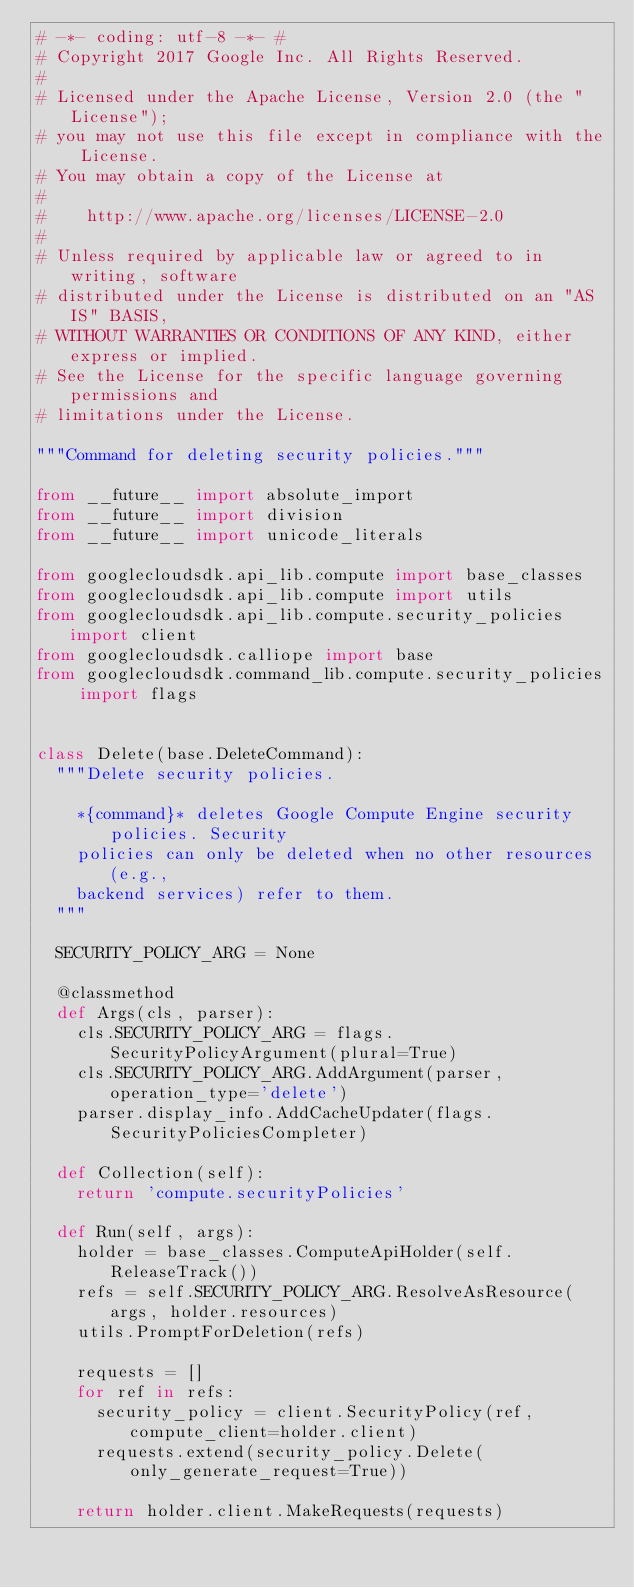Convert code to text. <code><loc_0><loc_0><loc_500><loc_500><_Python_># -*- coding: utf-8 -*- #
# Copyright 2017 Google Inc. All Rights Reserved.
#
# Licensed under the Apache License, Version 2.0 (the "License");
# you may not use this file except in compliance with the License.
# You may obtain a copy of the License at
#
#    http://www.apache.org/licenses/LICENSE-2.0
#
# Unless required by applicable law or agreed to in writing, software
# distributed under the License is distributed on an "AS IS" BASIS,
# WITHOUT WARRANTIES OR CONDITIONS OF ANY KIND, either express or implied.
# See the License for the specific language governing permissions and
# limitations under the License.

"""Command for deleting security policies."""

from __future__ import absolute_import
from __future__ import division
from __future__ import unicode_literals

from googlecloudsdk.api_lib.compute import base_classes
from googlecloudsdk.api_lib.compute import utils
from googlecloudsdk.api_lib.compute.security_policies import client
from googlecloudsdk.calliope import base
from googlecloudsdk.command_lib.compute.security_policies import flags


class Delete(base.DeleteCommand):
  """Delete security policies.

    *{command}* deletes Google Compute Engine security policies. Security
    policies can only be deleted when no other resources (e.g.,
    backend services) refer to them.
  """

  SECURITY_POLICY_ARG = None

  @classmethod
  def Args(cls, parser):
    cls.SECURITY_POLICY_ARG = flags.SecurityPolicyArgument(plural=True)
    cls.SECURITY_POLICY_ARG.AddArgument(parser, operation_type='delete')
    parser.display_info.AddCacheUpdater(flags.SecurityPoliciesCompleter)

  def Collection(self):
    return 'compute.securityPolicies'

  def Run(self, args):
    holder = base_classes.ComputeApiHolder(self.ReleaseTrack())
    refs = self.SECURITY_POLICY_ARG.ResolveAsResource(args, holder.resources)
    utils.PromptForDeletion(refs)

    requests = []
    for ref in refs:
      security_policy = client.SecurityPolicy(ref, compute_client=holder.client)
      requests.extend(security_policy.Delete(only_generate_request=True))

    return holder.client.MakeRequests(requests)
</code> 